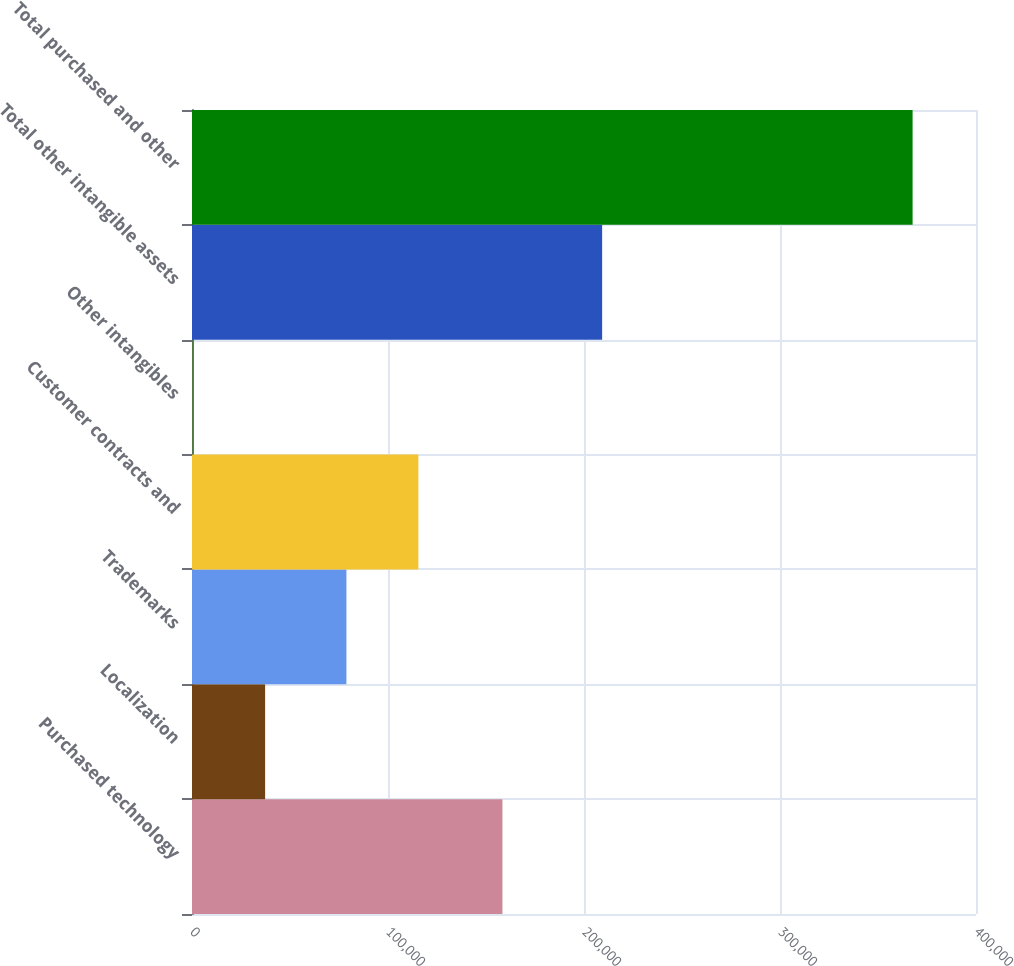Convert chart to OTSL. <chart><loc_0><loc_0><loc_500><loc_500><bar_chart><fcel>Purchased technology<fcel>Localization<fcel>Trademarks<fcel>Customer contracts and<fcel>Other intangibles<fcel>Total other intangible assets<fcel>Total purchased and other<nl><fcel>158389<fcel>37308<fcel>78782<fcel>115486<fcel>604<fcel>209255<fcel>367644<nl></chart> 